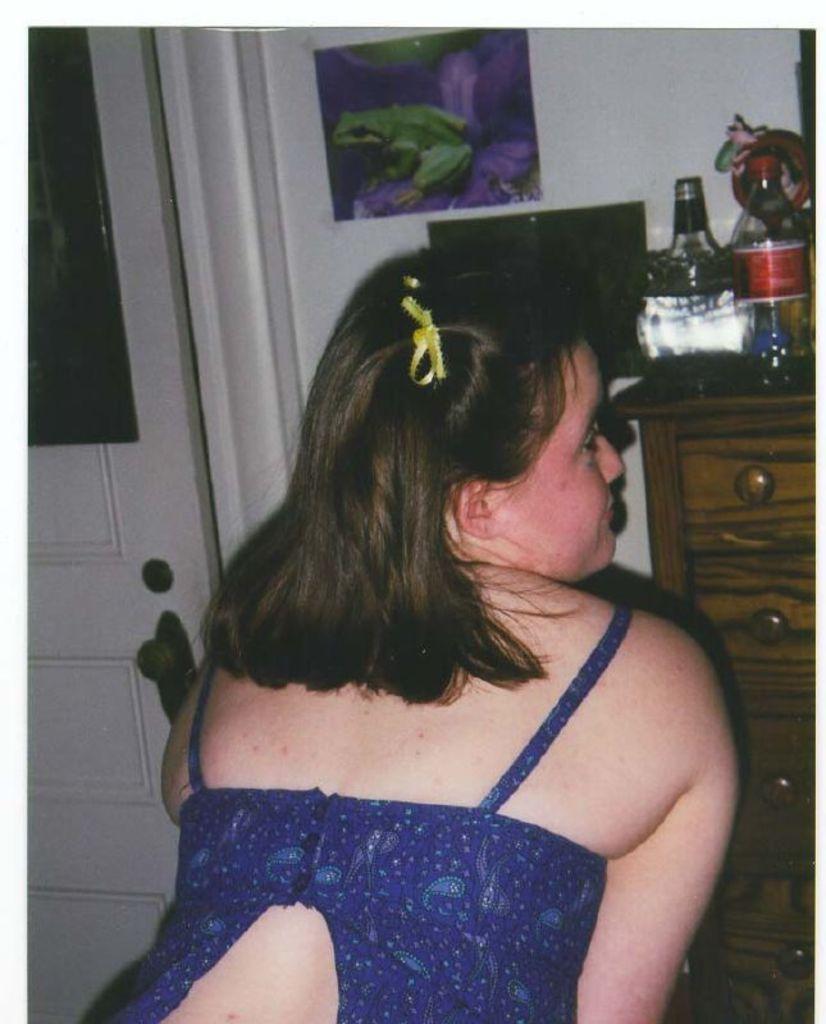How would you summarize this image in a sentence or two? There is a woman blue dress, at the left there is a door, at the back there is a wall. There is a picture of a frog on the wall , at the right there is a desk, there is a bottle on the desk. 